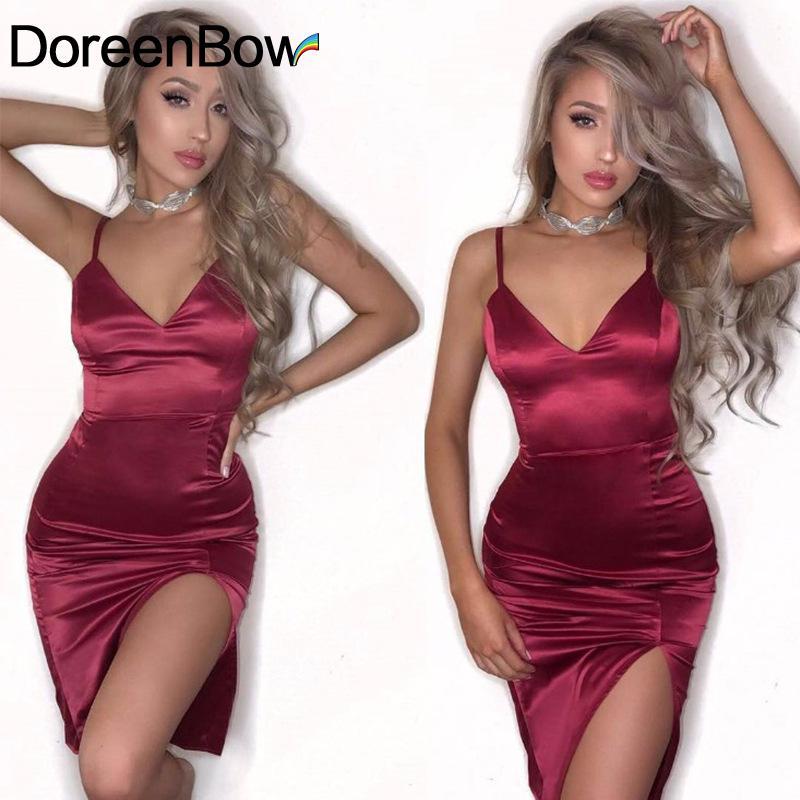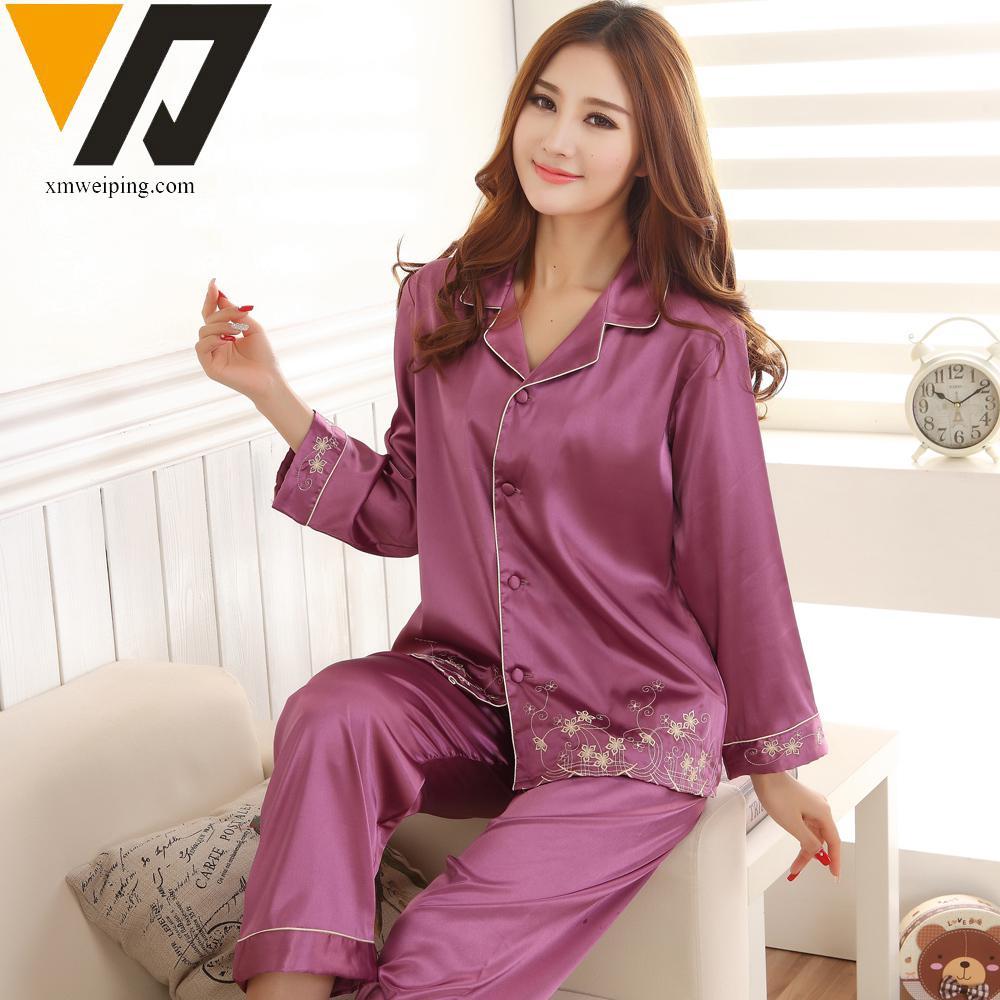The first image is the image on the left, the second image is the image on the right. Evaluate the accuracy of this statement regarding the images: "One image shows a model wearing a sleeved open-front top over a lace-trimmed garment with spaghetti straps.". Is it true? Answer yes or no. No. The first image is the image on the left, the second image is the image on the right. Assess this claim about the two images: "A pajama set worn by a woman in one image is made with a silky fabric with button-down long sleeve shirt, with cuffs on both the shirt sleeves and pant legs.". Correct or not? Answer yes or no. Yes. 